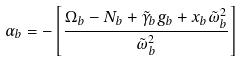<formula> <loc_0><loc_0><loc_500><loc_500>\alpha _ { b } = - \left [ \frac { \Omega _ { b } - N _ { b } + \tilde { \gamma } _ { b } g _ { b } + x _ { b } \tilde { \omega } _ { b } ^ { 2 } } { \tilde { \omega } _ { b } ^ { 2 } } \right ]</formula> 